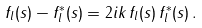<formula> <loc_0><loc_0><loc_500><loc_500>f _ { l } ( s ) - f _ { l } ^ { * } ( s ) = 2 i k \, f _ { l } ( s ) \, f _ { l } ^ { * } ( s ) \, .</formula> 